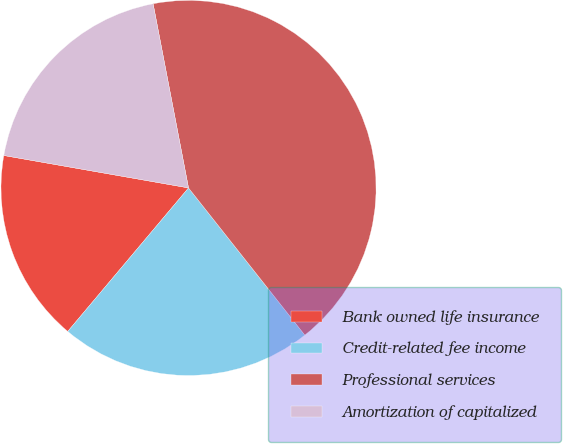<chart> <loc_0><loc_0><loc_500><loc_500><pie_chart><fcel>Bank owned life insurance<fcel>Credit-related fee income<fcel>Professional services<fcel>Amortization of capitalized<nl><fcel>16.63%<fcel>21.78%<fcel>42.38%<fcel>19.21%<nl></chart> 